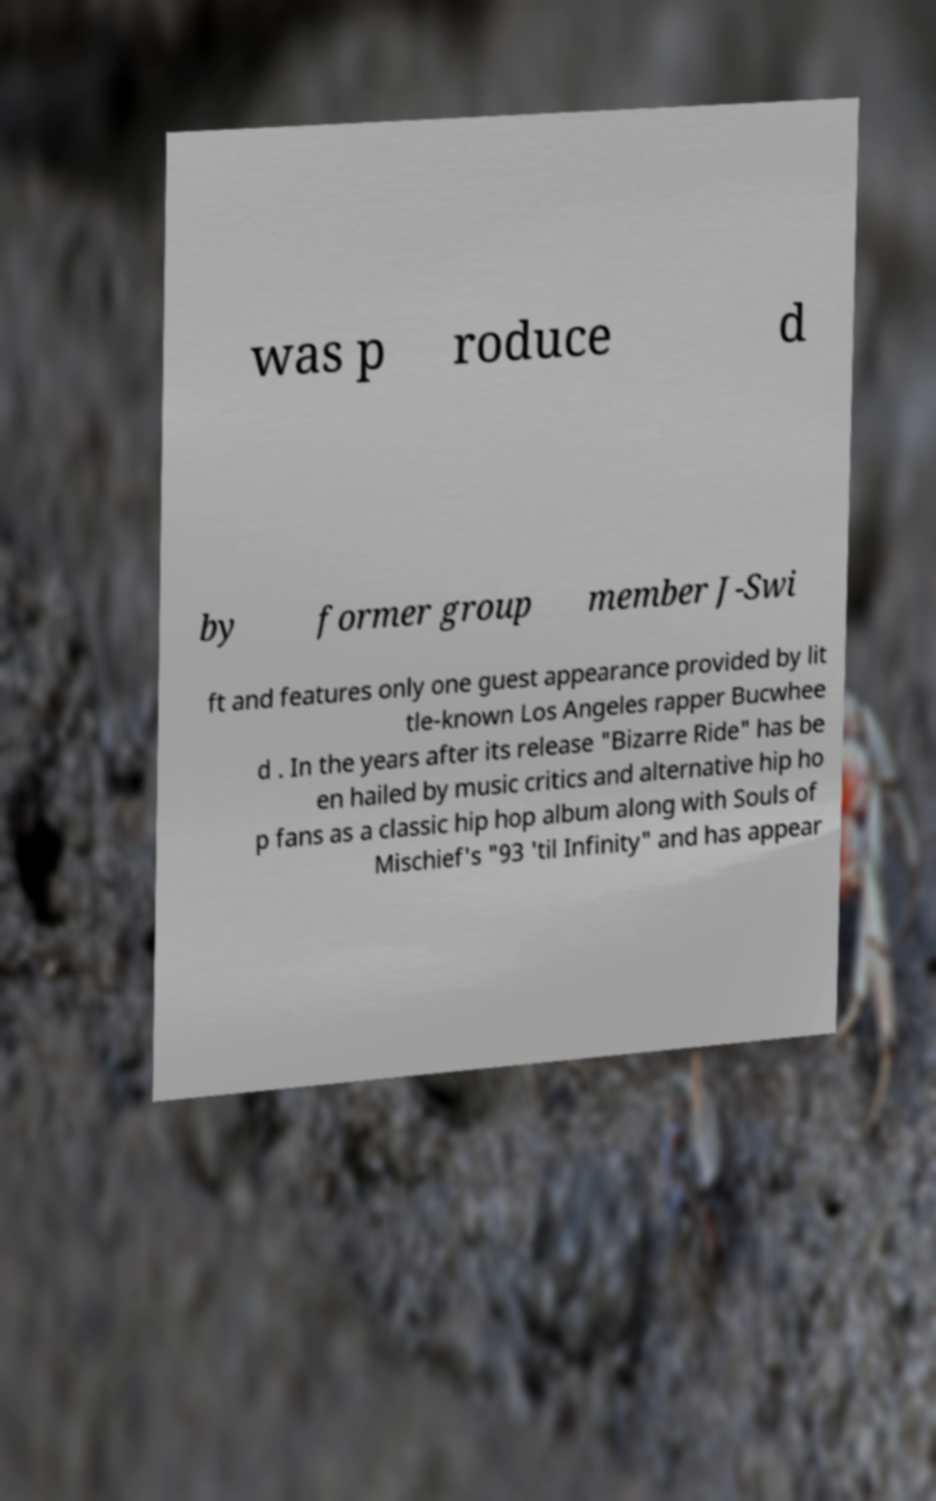Can you read and provide the text displayed in the image?This photo seems to have some interesting text. Can you extract and type it out for me? was p roduce d by former group member J-Swi ft and features only one guest appearance provided by lit tle-known Los Angeles rapper Bucwhee d . In the years after its release "Bizarre Ride" has be en hailed by music critics and alternative hip ho p fans as a classic hip hop album along with Souls of Mischief's "93 'til Infinity" and has appear 